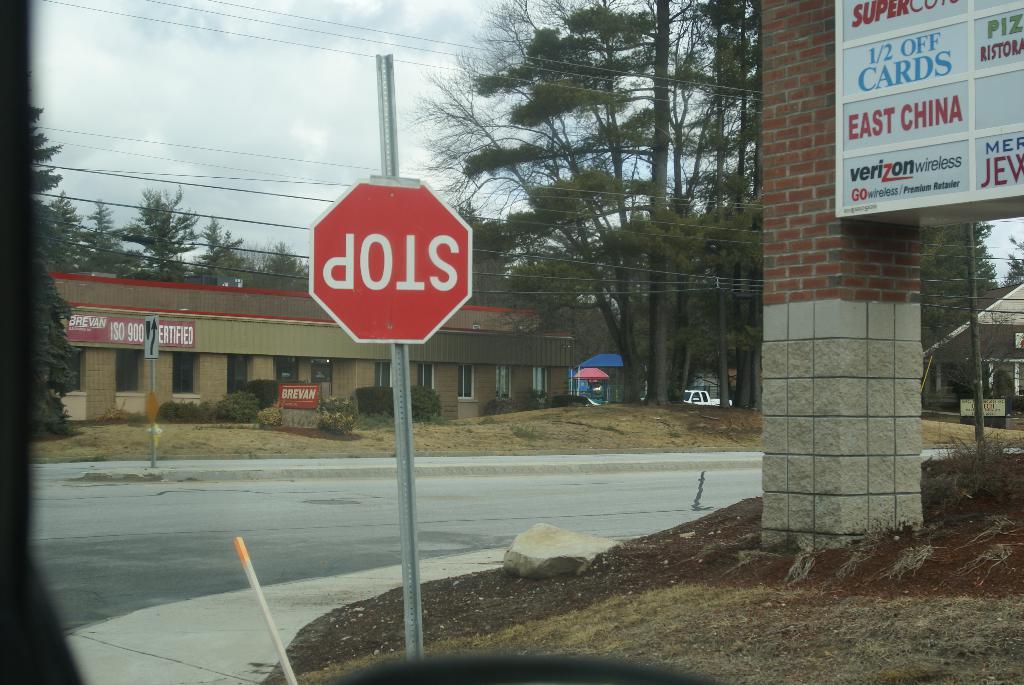What network service is advertised on the sign to the right?
Offer a very short reply. Verizon. What does the red octagon say on the post?
Make the answer very short. Stop. 